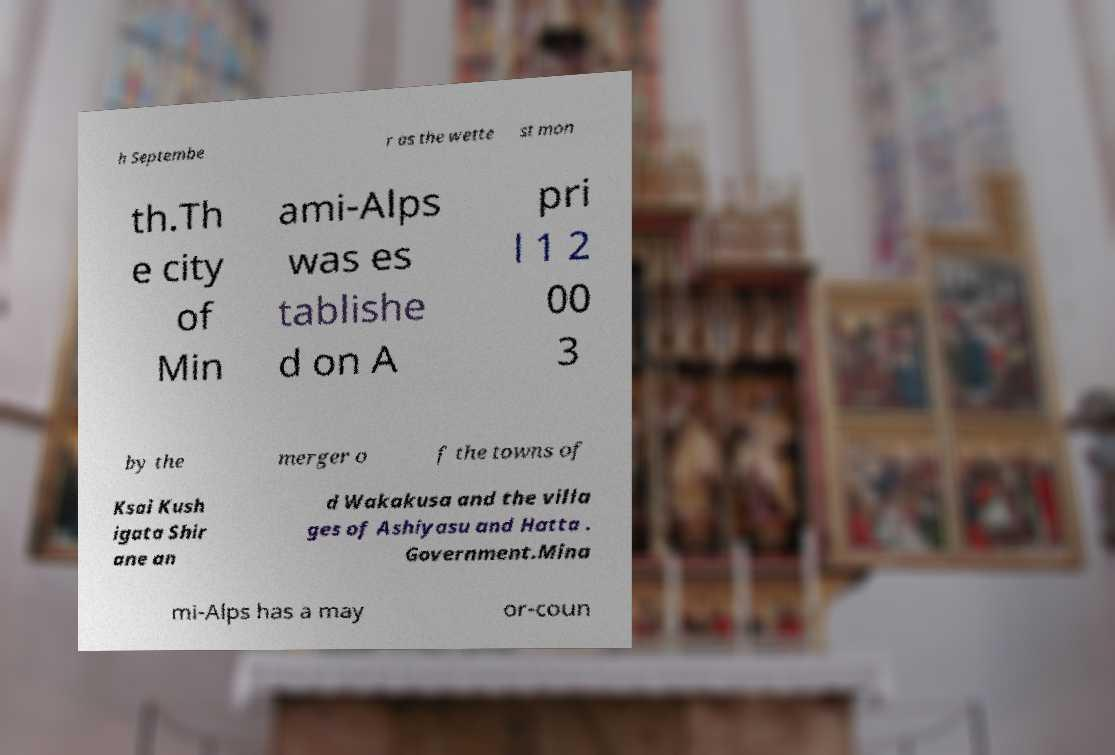What messages or text are displayed in this image? I need them in a readable, typed format. h Septembe r as the wette st mon th.Th e city of Min ami-Alps was es tablishe d on A pri l 1 2 00 3 by the merger o f the towns of Ksai Kush igata Shir ane an d Wakakusa and the villa ges of Ashiyasu and Hatta . Government.Mina mi-Alps has a may or-coun 